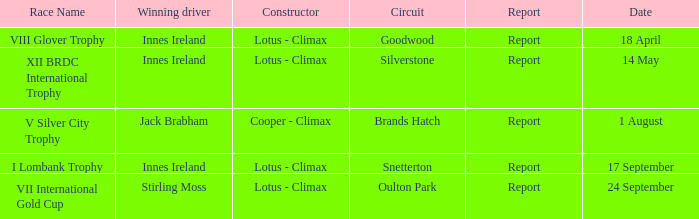What is the name of the race where Stirling Moss was the winning driver? VII International Gold Cup. 